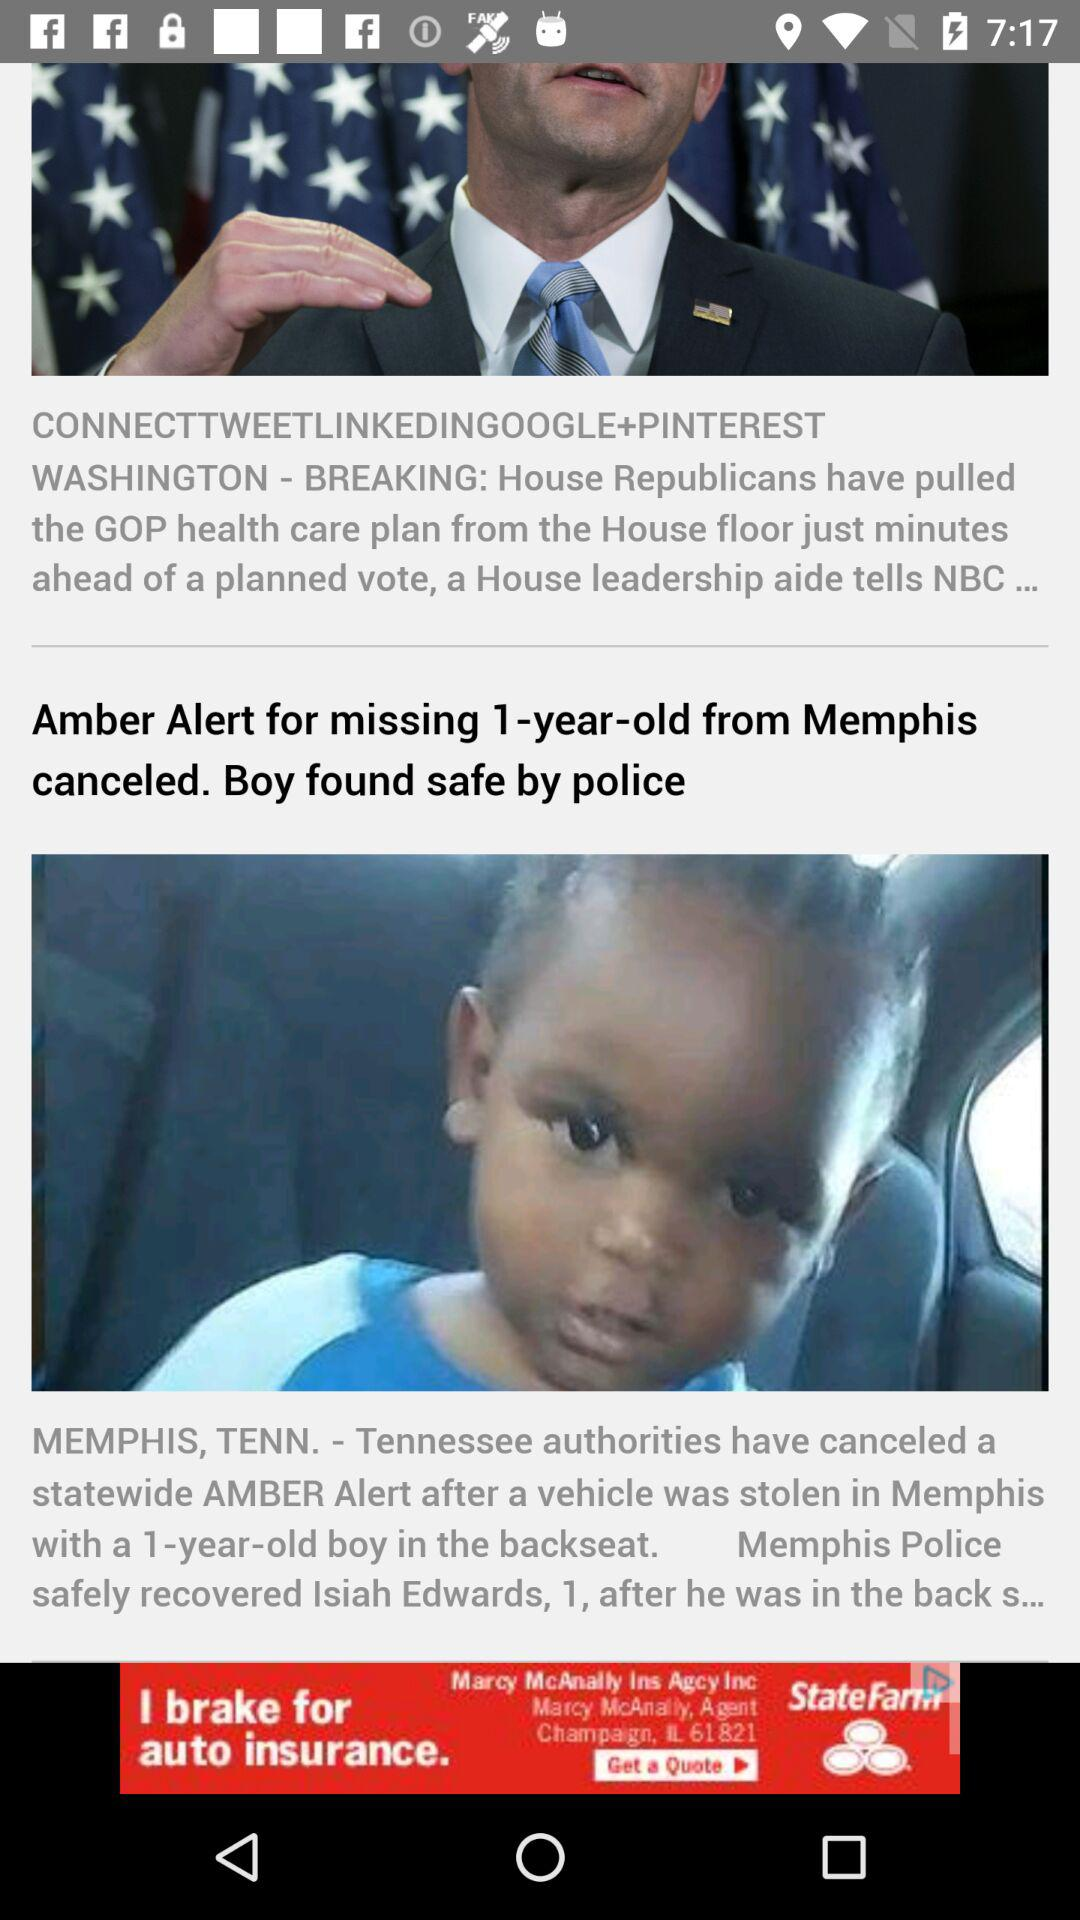What state authorities canceled an Amber Alert after a vehicle with a baby was stolen? The state authorities that canceled an Amber Alert after a vehicle with a baby was stolen is Tennessee. 